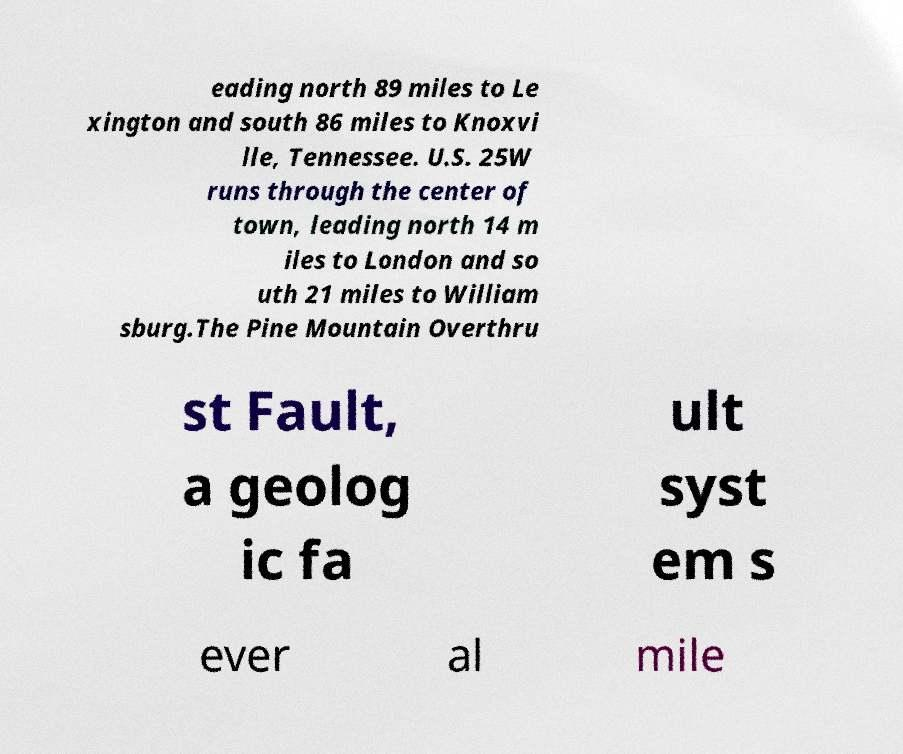Please read and relay the text visible in this image. What does it say? eading north 89 miles to Le xington and south 86 miles to Knoxvi lle, Tennessee. U.S. 25W runs through the center of town, leading north 14 m iles to London and so uth 21 miles to William sburg.The Pine Mountain Overthru st Fault, a geolog ic fa ult syst em s ever al mile 